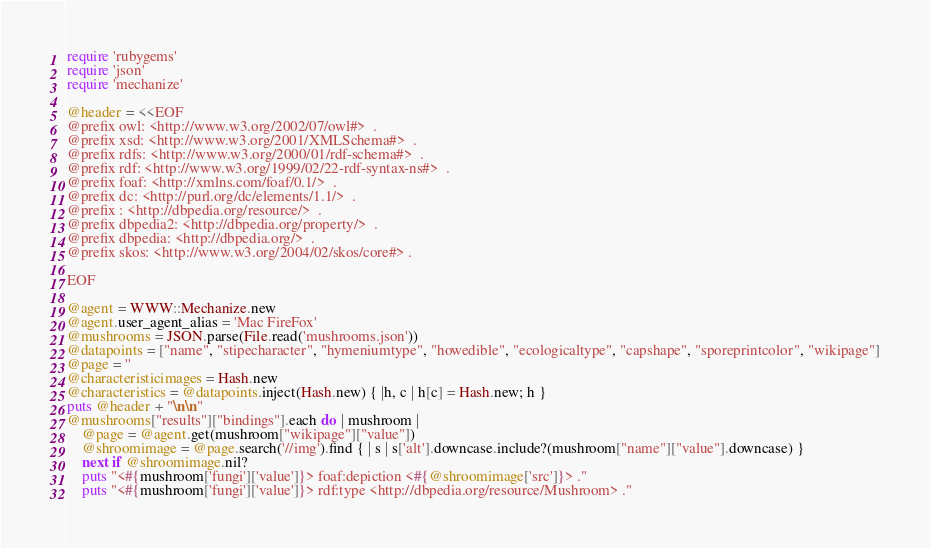Convert code to text. <code><loc_0><loc_0><loc_500><loc_500><_Ruby_>require 'rubygems'
require 'json'
require 'mechanize'

@header = <<EOF
@prefix owl: <http://www.w3.org/2002/07/owl#>  .
@prefix xsd: <http://www.w3.org/2001/XMLSchema#>  .
@prefix rdfs: <http://www.w3.org/2000/01/rdf-schema#>  .
@prefix rdf: <http://www.w3.org/1999/02/22-rdf-syntax-ns#>  .
@prefix foaf: <http://xmlns.com/foaf/0.1/>  .
@prefix dc: <http://purl.org/dc/elements/1.1/>  .
@prefix : <http://dbpedia.org/resource/>  .
@prefix dbpedia2: <http://dbpedia.org/property/>  .
@prefix dbpedia: <http://dbpedia.org/>  .
@prefix skos: <http://www.w3.org/2004/02/skos/core#> .

EOF

@agent = WWW::Mechanize.new
@agent.user_agent_alias = 'Mac FireFox'
@mushrooms = JSON.parse(File.read('mushrooms.json'))
@datapoints = ["name", "stipecharacter", "hymeniumtype", "howedible", "ecologicaltype", "capshape", "sporeprintcolor", "wikipage"]
@page = ''
@characteristicimages = Hash.new
@characteristics = @datapoints.inject(Hash.new) { |h, c | h[c] = Hash.new; h }
puts @header + "\n\n"
@mushrooms["results"]["bindings"].each do | mushroom |
	@page = @agent.get(mushroom["wikipage"]["value"])
	@shroomimage = @page.search('//img').find { | s | s['alt'].downcase.include?(mushroom["name"]["value"].downcase) }
	next if @shroomimage.nil?
	puts "<#{mushroom['fungi']['value']}> foaf:depiction <#{@shroomimage['src']}> ."
	puts "<#{mushroom['fungi']['value']}> rdf:type <http://dbpedia.org/resource/Mushroom> ."</code> 